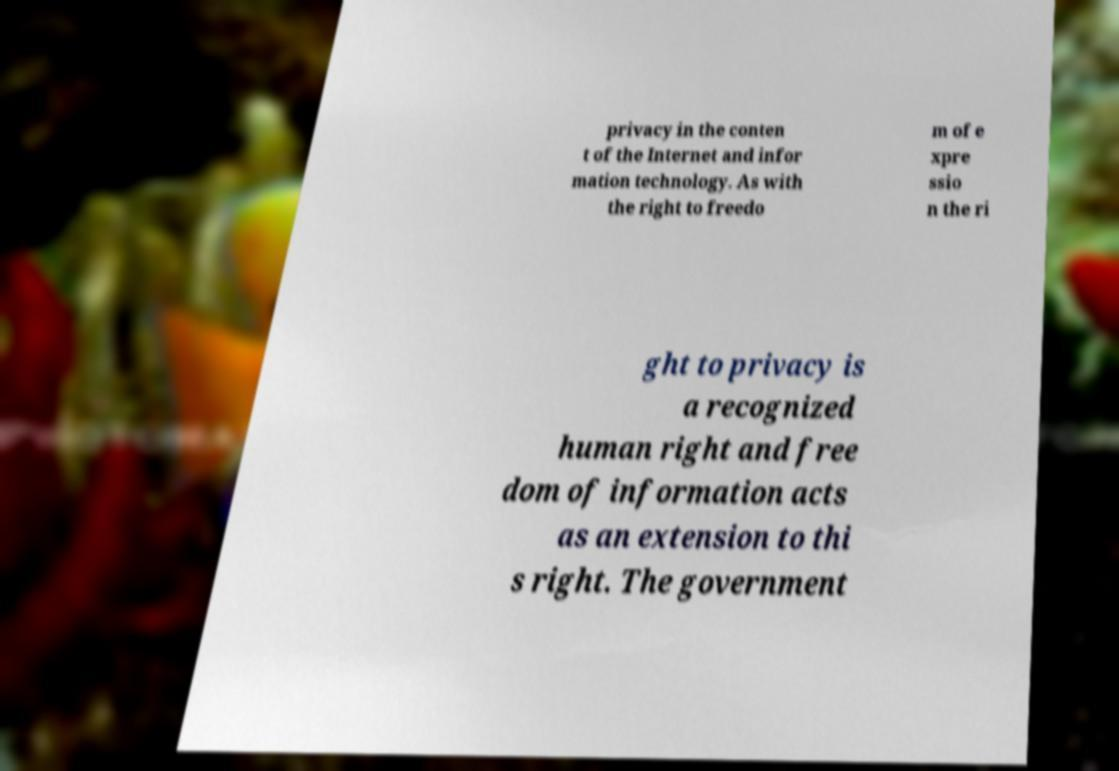What messages or text are displayed in this image? I need them in a readable, typed format. privacy in the conten t of the Internet and infor mation technology. As with the right to freedo m of e xpre ssio n the ri ght to privacy is a recognized human right and free dom of information acts as an extension to thi s right. The government 